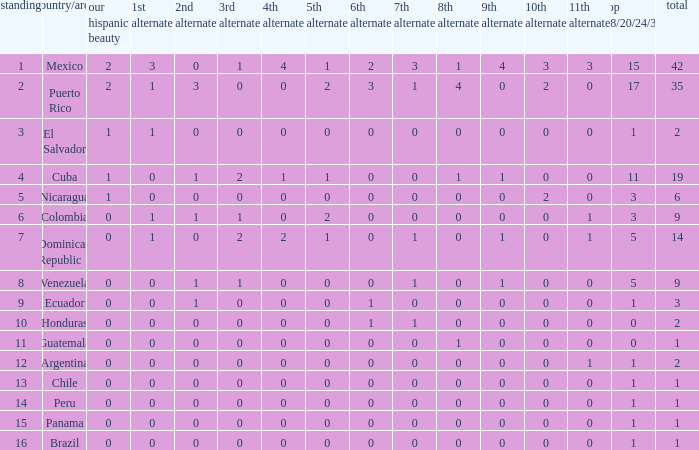Write the full table. {'header': ['standing', 'country/area', 'our hispanic beauty', '1st alternate', '2nd alternate', '3rd alternate', '4th alternate', '5th alternate', '6th alternate', '7th alternate', '8th alternate', '9th alternate', '10th alternate', '11th alternate', 'top 18/20/24/30', 'total'], 'rows': [['1', 'Mexico', '2', '3', '0', '1', '4', '1', '2', '3', '1', '4', '3', '3', '15', '42'], ['2', 'Puerto Rico', '2', '1', '3', '0', '0', '2', '3', '1', '4', '0', '2', '0', '17', '35'], ['3', 'El Salvador', '1', '1', '0', '0', '0', '0', '0', '0', '0', '0', '0', '0', '1', '2'], ['4', 'Cuba', '1', '0', '1', '2', '1', '1', '0', '0', '1', '1', '0', '0', '11', '19'], ['5', 'Nicaragua', '1', '0', '0', '0', '0', '0', '0', '0', '0', '0', '2', '0', '3', '6'], ['6', 'Colombia', '0', '1', '1', '1', '0', '2', '0', '0', '0', '0', '0', '1', '3', '9'], ['7', 'Dominican Republic', '0', '1', '0', '2', '2', '1', '0', '1', '0', '1', '0', '1', '5', '14'], ['8', 'Venezuela', '0', '0', '1', '1', '0', '0', '0', '1', '0', '1', '0', '0', '5', '9'], ['9', 'Ecuador', '0', '0', '1', '0', '0', '0', '1', '0', '0', '0', '0', '0', '1', '3'], ['10', 'Honduras', '0', '0', '0', '0', '0', '0', '1', '1', '0', '0', '0', '0', '0', '2'], ['11', 'Guatemala', '0', '0', '0', '0', '0', '0', '0', '0', '1', '0', '0', '0', '0', '1'], ['12', 'Argentina', '0', '0', '0', '0', '0', '0', '0', '0', '0', '0', '0', '1', '1', '2'], ['13', 'Chile', '0', '0', '0', '0', '0', '0', '0', '0', '0', '0', '0', '0', '1', '1'], ['14', 'Peru', '0', '0', '0', '0', '0', '0', '0', '0', '0', '0', '0', '0', '1', '1'], ['15', 'Panama', '0', '0', '0', '0', '0', '0', '0', '0', '0', '0', '0', '0', '1', '1'], ['16', 'Brazil', '0', '0', '0', '0', '0', '0', '0', '0', '0', '0', '0', '0', '1', '1']]} What is the average total of the country with a 4th runner-up of 0 and a Nuestra Bellaza Latina less than 0? None. 